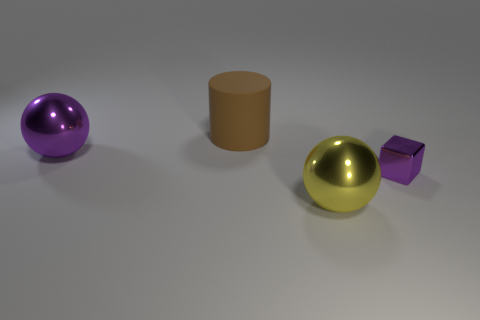How many metallic objects are either red balls or large objects?
Ensure brevity in your answer.  2. Are there any other things that have the same material as the yellow sphere?
Offer a terse response. Yes. What is the size of the metallic thing that is right of the large metallic thing in front of the large metal ball that is behind the tiny object?
Your answer should be very brief. Small. There is a thing that is both behind the large yellow object and in front of the big purple ball; what is its size?
Provide a short and direct response. Small. Is the color of the thing that is left of the brown matte thing the same as the object on the right side of the yellow metallic ball?
Your answer should be compact. Yes. How many cubes are to the left of the large yellow object?
Keep it short and to the point. 0. Is there a brown matte object that is behind the shiny block in front of the big metallic thing that is behind the yellow thing?
Provide a short and direct response. Yes. What number of things are the same size as the cylinder?
Give a very brief answer. 2. What material is the big object that is in front of the large metal object that is behind the tiny shiny cube?
Your answer should be compact. Metal. There is a purple shiny object to the left of the purple object that is to the right of the large metallic sphere behind the yellow sphere; what shape is it?
Your answer should be compact. Sphere. 